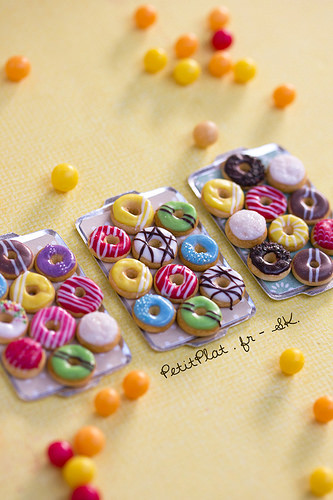<image>
Is the donut on the platter? Yes. Looking at the image, I can see the donut is positioned on top of the platter, with the platter providing support. Is there a donut on the tray? No. The donut is not positioned on the tray. They may be near each other, but the donut is not supported by or resting on top of the tray. 